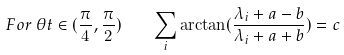<formula> <loc_0><loc_0><loc_500><loc_500>F o r \, \theta t \in ( \frac { \pi } { 4 } , \frac { \pi } { 2 } ) \quad \sum _ { i } \arctan ( \frac { \lambda _ { i } + a - b } { \lambda _ { i } + a + b } ) = c \,</formula> 